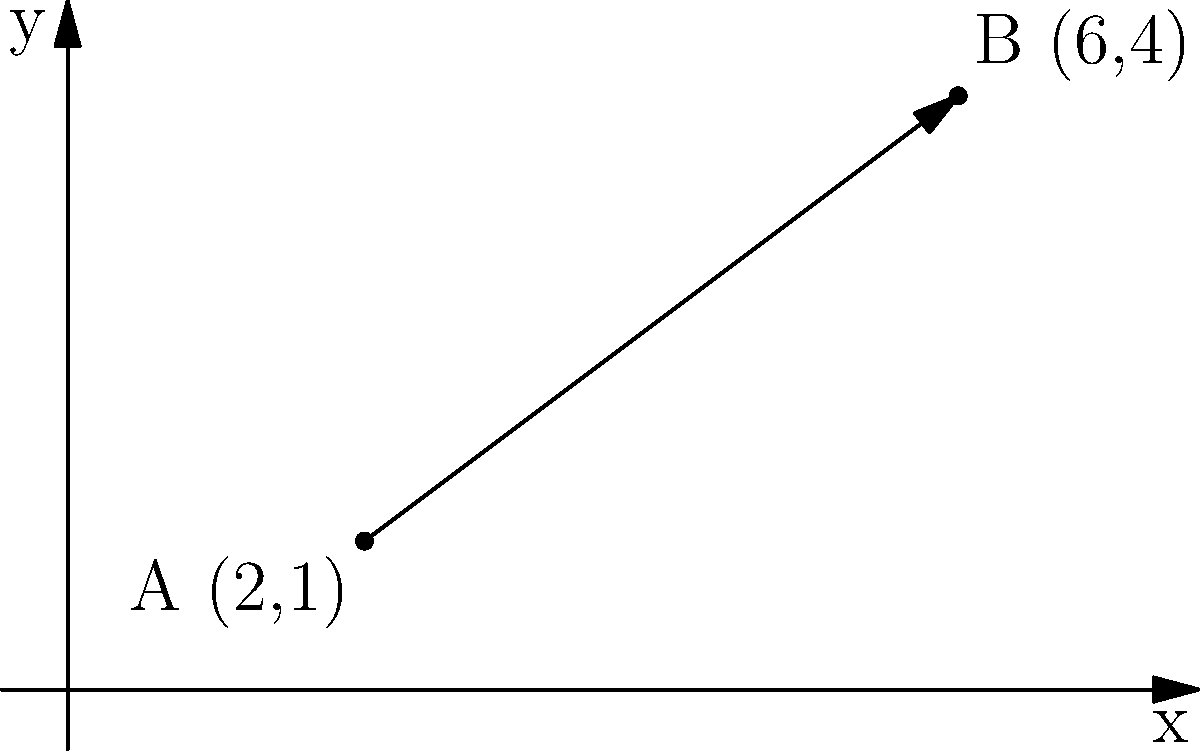A poetry recital event is planned, starting at point A (2,1) and ending at point B (6,4) on a coordinate plane representing the venue layout. Find the slope of the line passing through these points and determine its equation in slope-intercept form. To solve this problem, we'll follow these steps:

1. Calculate the slope of the line:
   The slope formula is $m = \frac{y_2 - y_1}{x_2 - x_1}$
   
   $m = \frac{4 - 1}{6 - 2} = \frac{3}{4} = 0.75$

2. Use the point-slope form of a line to create an equation:
   $y - y_1 = m(x - x_1)$
   
   Let's use point A (2,1):
   $y - 1 = \frac{3}{4}(x - 2)$

3. Expand the equation:
   $y - 1 = \frac{3}{4}x - \frac{3}{2}$

4. Solve for y to get the slope-intercept form $(y = mx + b)$:
   $y = \frac{3}{4}x - \frac{3}{2} + 1$
   $y = \frac{3}{4}x - \frac{1}{2}$

Therefore, the slope of the line is $\frac{3}{4}$ or 0.75, and the equation of the line in slope-intercept form is $y = \frac{3}{4}x - \frac{1}{2}$.
Answer: Slope: $\frac{3}{4}$; Equation: $y = \frac{3}{4}x - \frac{1}{2}$ 